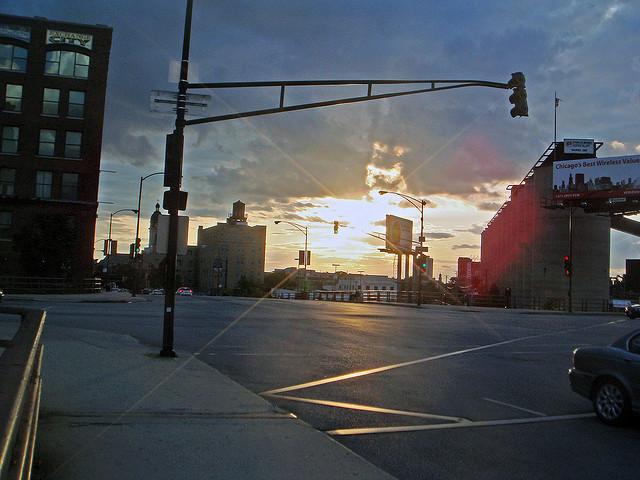Is there a bus stop on this street?
Be succinct. No. How many cars are at the intersection?
Give a very brief answer. 1. Is that a front or rear bumper on the car?
Short answer required. Rear. Are the cars driving on the right side or on the left side of the road?
Answer briefly. Right. What time of day is this?
Write a very short answer. Evening. Is there a dog in the photo?
Give a very brief answer. No. Is the skateboard on the ground or in the air?
Short answer required. Ground. How many cars are crossing the street?
Be succinct. 1. How many billboards is in the scene?
Write a very short answer. 2. Is there a train?
Write a very short answer. No. What do diagonal lines indicate?
Give a very brief answer. Crosswalk. Why are the street lights on?
Quick response, please. Nighttime. Is this too many traffic lights?
Be succinct. No. 